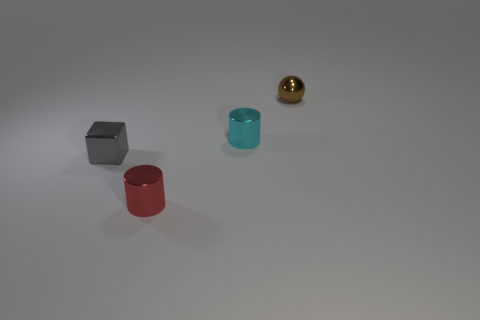Is there anything else that is the same shape as the tiny gray object?
Offer a very short reply. No. Are there more metallic things that are to the right of the brown ball than gray blocks that are left of the gray block?
Your answer should be very brief. No. There is a cyan cylinder that is the same size as the gray cube; what is it made of?
Ensure brevity in your answer.  Metal. How many small objects are cyan things or brown shiny objects?
Make the answer very short. 2. Is the shape of the gray metal object the same as the small cyan object?
Ensure brevity in your answer.  No. What number of metal objects are both in front of the brown shiny sphere and right of the tiny red cylinder?
Provide a succinct answer. 1. Is there anything else that is the same color as the small metallic cube?
Keep it short and to the point. No. What shape is the red thing that is made of the same material as the small gray object?
Keep it short and to the point. Cylinder. Does the gray block have the same size as the ball?
Ensure brevity in your answer.  Yes. Are there any other things that have the same material as the block?
Your answer should be compact. Yes. 